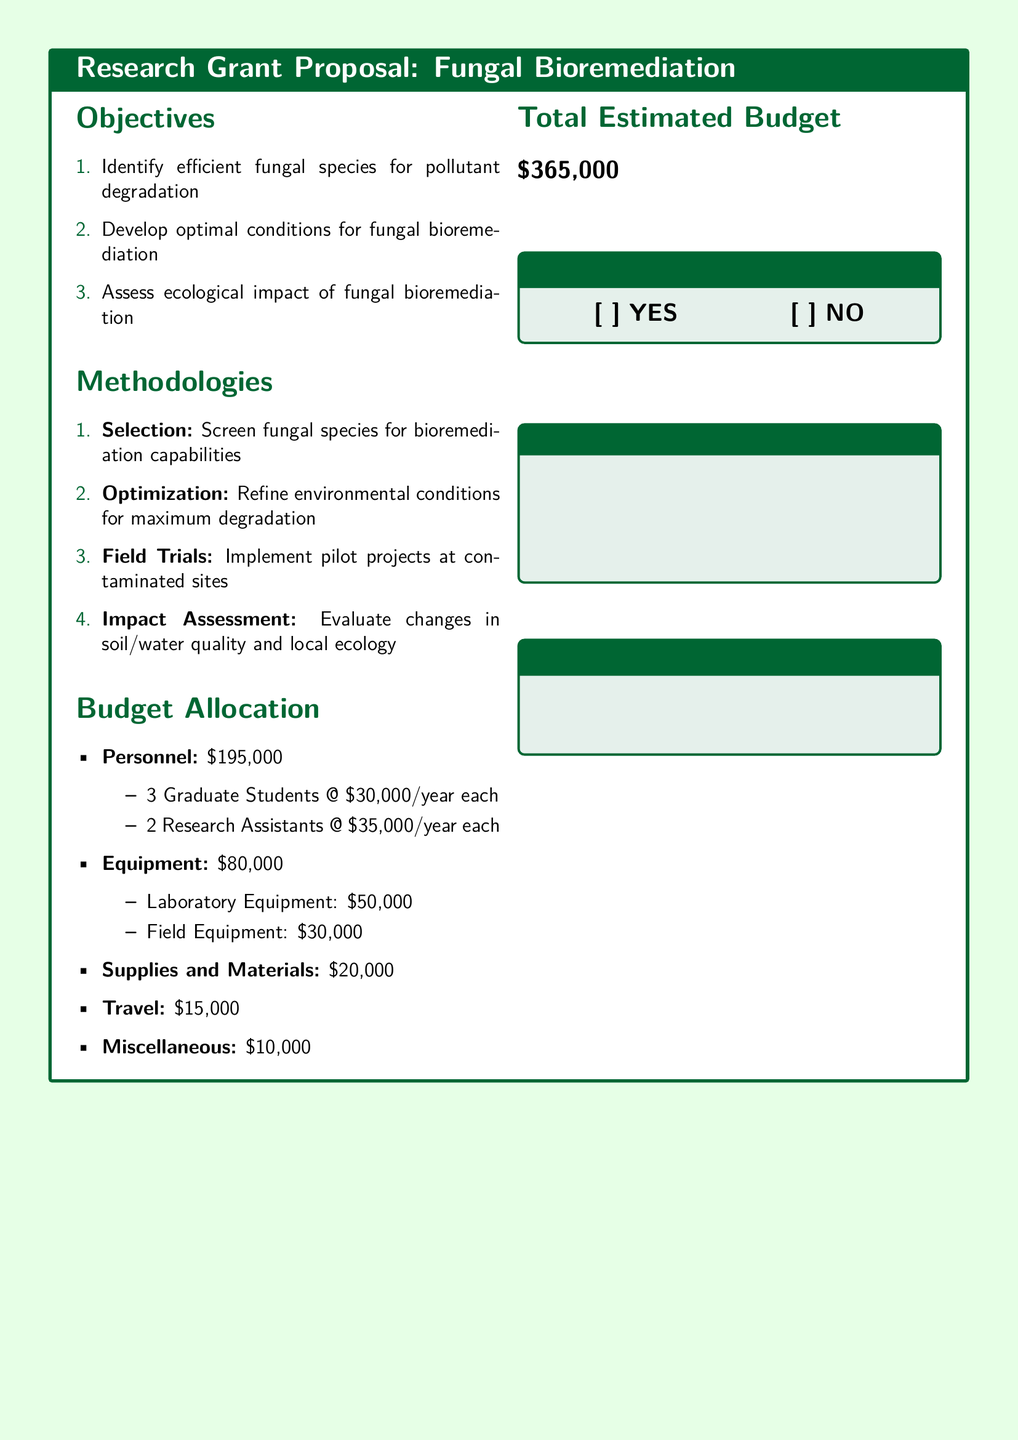What are the main objectives of the proposal? The objectives listed in the document are to identify efficient fungal species for pollutant degradation, develop optimal conditions for fungal bioremediation, and assess ecological impact of fungal bioremediation.
Answer: Identify efficient fungal species for pollutant degradation, develop optimal conditions for fungal bioremediation, assess ecological impact of fungal bioremediation How much is allocated for personnel? The budget allocation specifies that personnel costs total $195,000.
Answer: $195,000 What is the total estimated budget for the project? The total estimated budget is stated directly in the document as $365,000.
Answer: $365,000 How many graduate students are included in the personnel budget? The personnel budget mentions three graduate students at $30,000 per year each.
Answer: 3 What is the purpose of the field trials mentioned in the methodologies? Field trials are implemented for conducting pilot projects at contaminated sites and assessing the impact of the bioremediation efforts.
Answer: Implement pilot projects at contaminated sites What is the total budget for travel? The travel budget is explicitly specified as $15,000 in the document.
Answer: $15,000 Which type of equipment has the highest cost in the budget? The laboratory equipment is listed as costing $50,000, which is higher than the field equipment cost.
Answer: Laboratory Equipment How are the approval options presented in the document? The document includes a section titled "Vote for Approval" with options for "YES" and "NO."
Answer: YES and NO What section follows the budget allocation in the proposal? The section that follows the budget allocation is "Total Estimated Budget."
Answer: Total Estimated Budget 